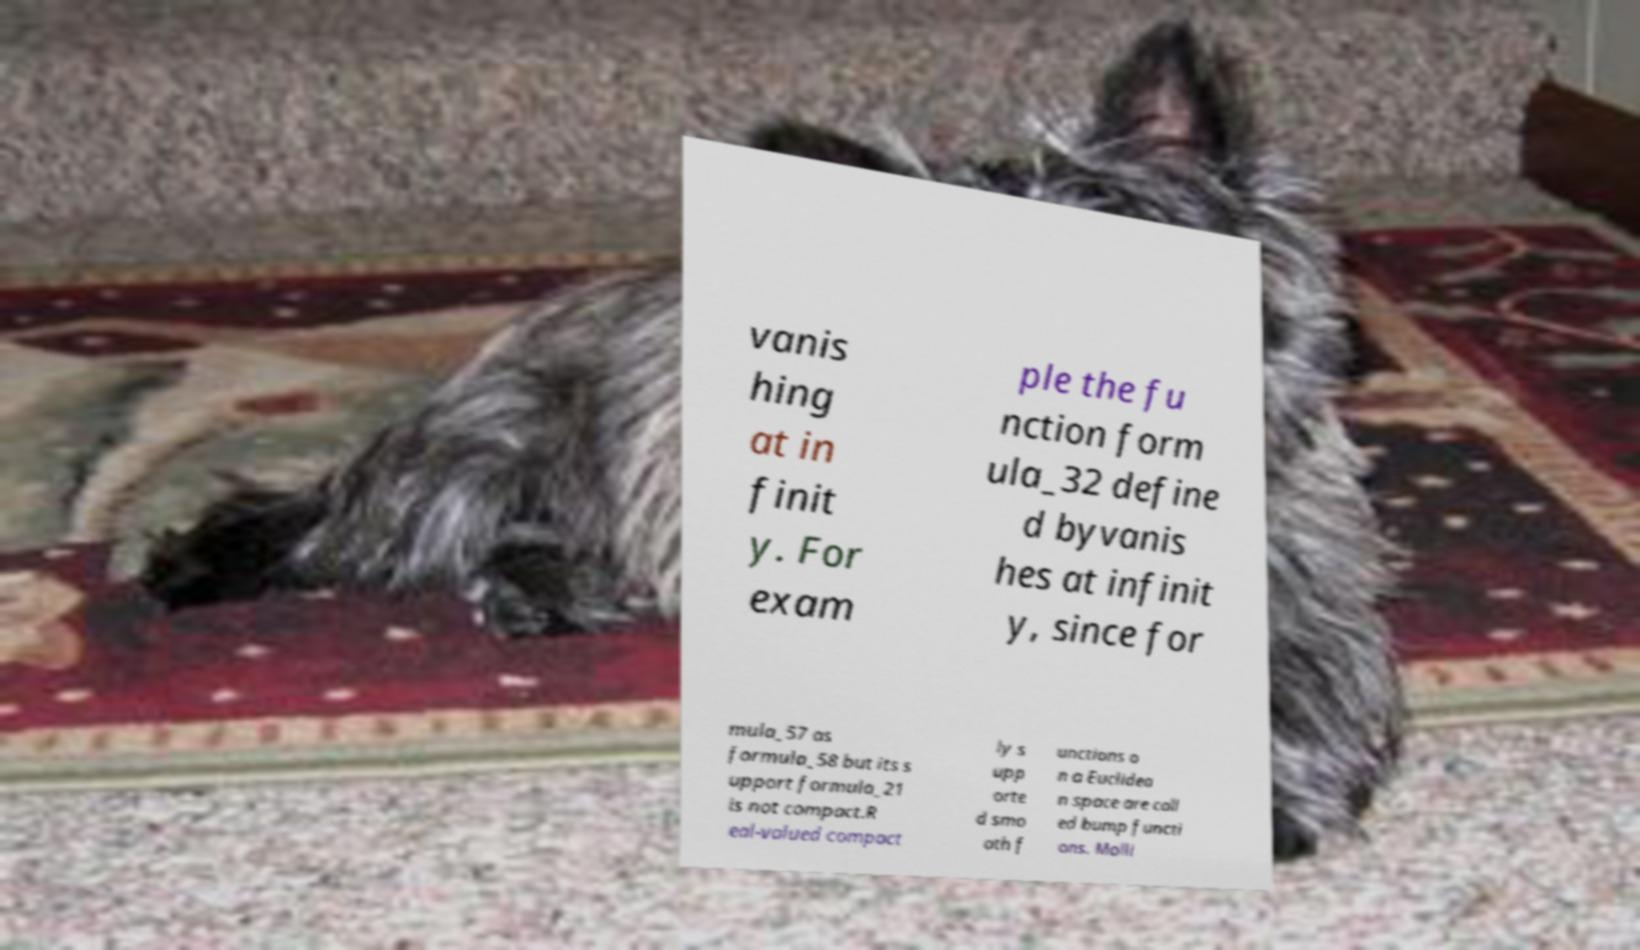What messages or text are displayed in this image? I need them in a readable, typed format. vanis hing at in finit y. For exam ple the fu nction form ula_32 define d byvanis hes at infinit y, since for mula_57 as formula_58 but its s upport formula_21 is not compact.R eal-valued compact ly s upp orte d smo oth f unctions o n a Euclidea n space are call ed bump functi ons. Molli 